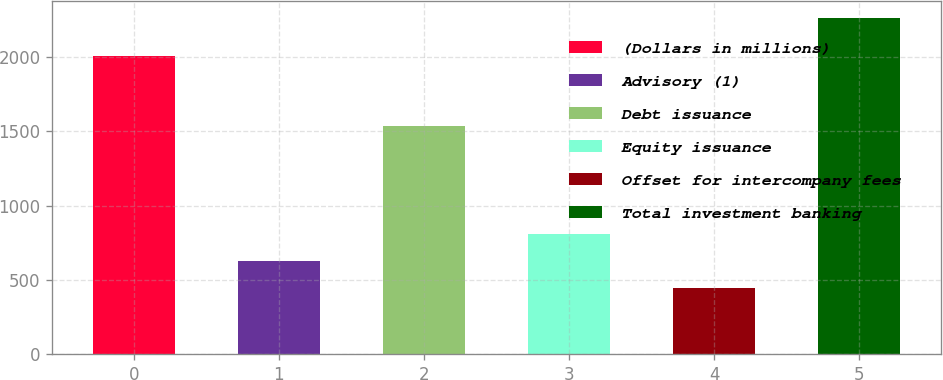Convert chart to OTSL. <chart><loc_0><loc_0><loc_500><loc_500><bar_chart><fcel>(Dollars in millions)<fcel>Advisory (1)<fcel>Debt issuance<fcel>Equity issuance<fcel>Offset for intercompany fees<fcel>Total investment banking<nl><fcel>2008<fcel>627.7<fcel>1539<fcel>809.4<fcel>446<fcel>2263<nl></chart> 